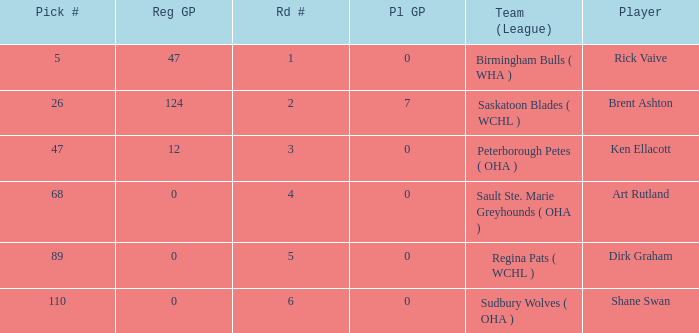How many reg GP for rick vaive in round 1? None. Could you parse the entire table? {'header': ['Pick #', 'Reg GP', 'Rd #', 'Pl GP', 'Team (League)', 'Player'], 'rows': [['5', '47', '1', '0', 'Birmingham Bulls ( WHA )', 'Rick Vaive'], ['26', '124', '2', '7', 'Saskatoon Blades ( WCHL )', 'Brent Ashton'], ['47', '12', '3', '0', 'Peterborough Petes ( OHA )', 'Ken Ellacott'], ['68', '0', '4', '0', 'Sault Ste. Marie Greyhounds ( OHA )', 'Art Rutland'], ['89', '0', '5', '0', 'Regina Pats ( WCHL )', 'Dirk Graham'], ['110', '0', '6', '0', 'Sudbury Wolves ( OHA )', 'Shane Swan']]} 